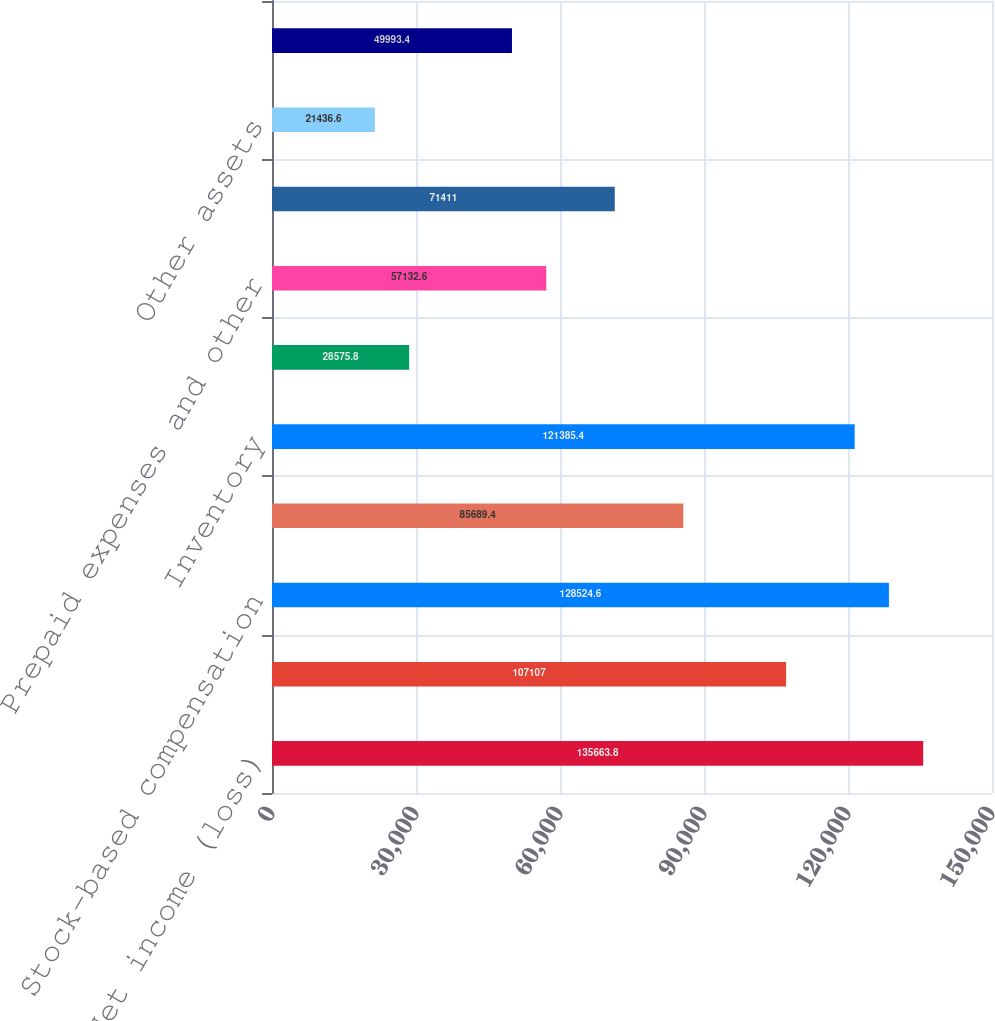<chart> <loc_0><loc_0><loc_500><loc_500><bar_chart><fcel>Net income (loss)<fcel>Depreciation and amortization<fcel>Stock-based compensation<fcel>Accounts receivable-net<fcel>Inventory<fcel>Deferred tax assets<fcel>Prepaid expenses and other<fcel>Deferred cost of revenues<fcel>Other assets<fcel>Accounts payable<nl><fcel>135664<fcel>107107<fcel>128525<fcel>85689.4<fcel>121385<fcel>28575.8<fcel>57132.6<fcel>71411<fcel>21436.6<fcel>49993.4<nl></chart> 